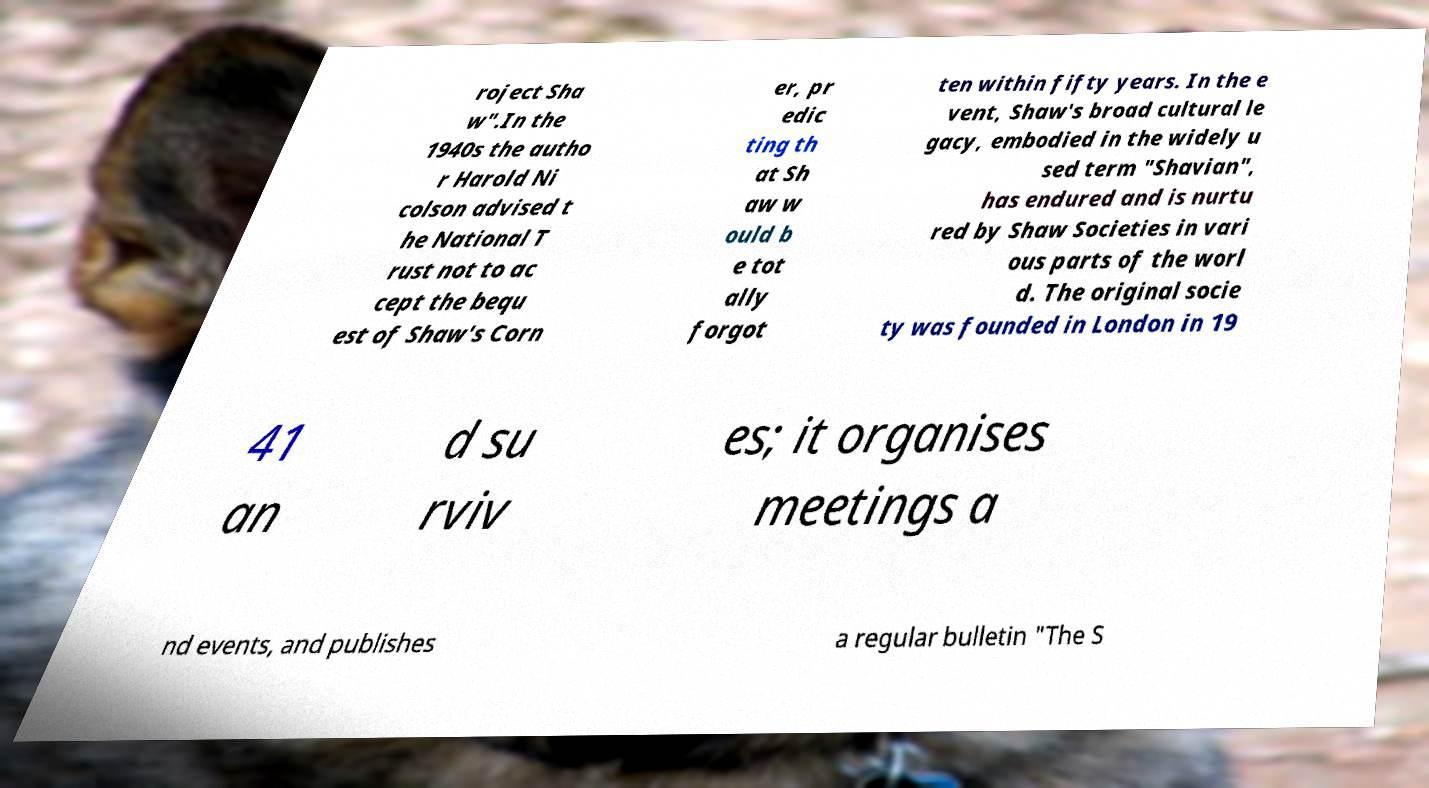Could you extract and type out the text from this image? roject Sha w".In the 1940s the autho r Harold Ni colson advised t he National T rust not to ac cept the bequ est of Shaw's Corn er, pr edic ting th at Sh aw w ould b e tot ally forgot ten within fifty years. In the e vent, Shaw's broad cultural le gacy, embodied in the widely u sed term "Shavian", has endured and is nurtu red by Shaw Societies in vari ous parts of the worl d. The original socie ty was founded in London in 19 41 an d su rviv es; it organises meetings a nd events, and publishes a regular bulletin "The S 